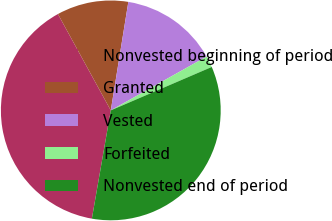<chart> <loc_0><loc_0><loc_500><loc_500><pie_chart><fcel>Nonvested beginning of period<fcel>Granted<fcel>Vested<fcel>Forfeited<fcel>Nonvested end of period<nl><fcel>39.26%<fcel>10.54%<fcel>14.3%<fcel>1.68%<fcel>34.22%<nl></chart> 